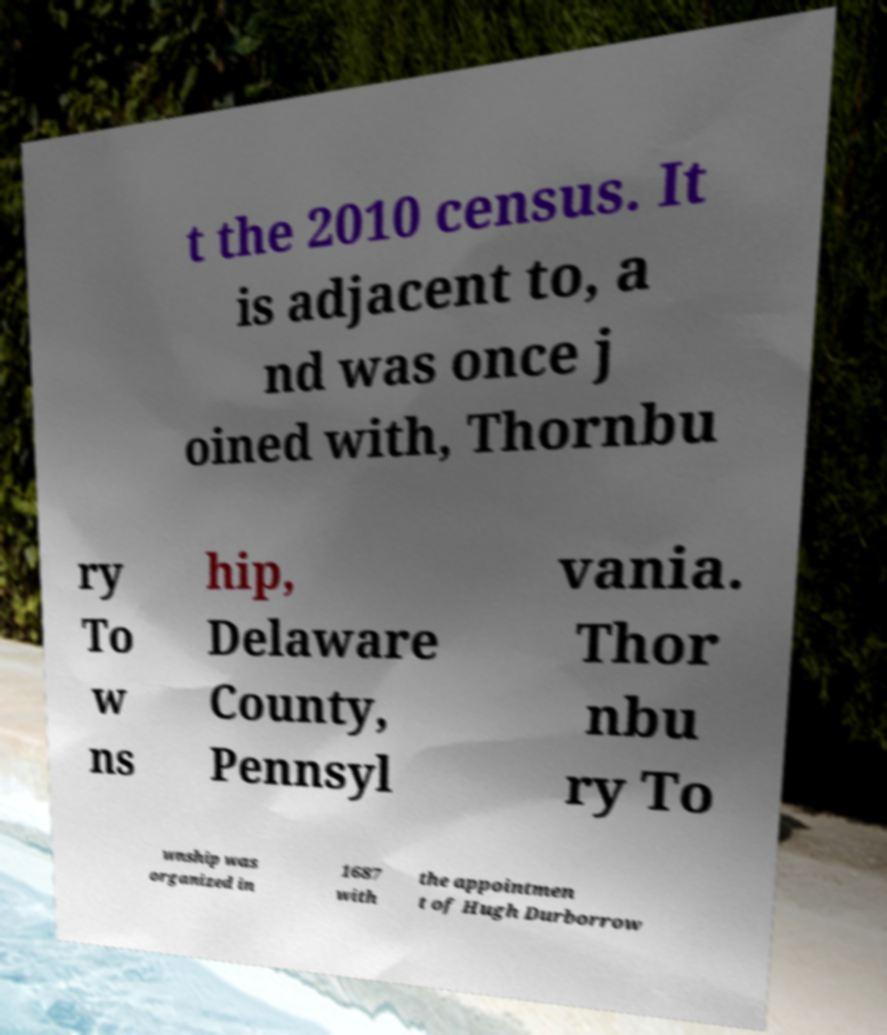Can you accurately transcribe the text from the provided image for me? t the 2010 census. It is adjacent to, a nd was once j oined with, Thornbu ry To w ns hip, Delaware County, Pennsyl vania. Thor nbu ry To wnship was organized in 1687 with the appointmen t of Hugh Durborrow 